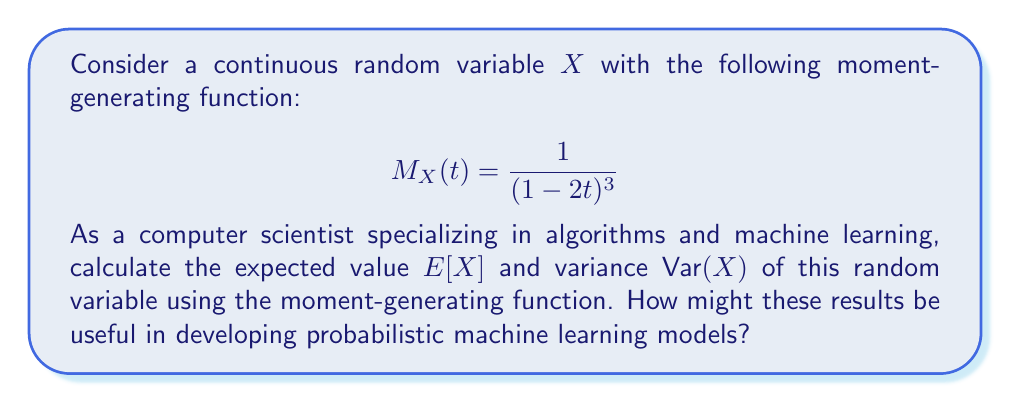Provide a solution to this math problem. To solve this problem, we'll use the properties of moment-generating functions (MGF) to calculate the expected value and variance.

Step 1: Calculate $E[X]$
The expected value is given by the first derivative of the MGF evaluated at $t=0$:

$$E[X] = M'_X(0)$$

Let's find $M'_X(t)$:

$$M'_X(t) = \frac{d}{dt}\left(\frac{1}{(1-2t)^3}\right) = \frac{6}{(1-2t)^4}$$

Now, evaluate at $t=0$:

$$E[X] = M'_X(0) = \frac{6}{(1-2(0))^4} = 6$$

Step 2: Calculate $E[X^2]$
To find the variance, we need $E[X^2]$, which is given by the second derivative of the MGF evaluated at $t=0$:

$$E[X^2] = M''_X(0)$$

Let's find $M''_X(t)$:

$$M''_X(t) = \frac{d}{dt}\left(\frac{6}{(1-2t)^4}\right) = \frac{48}{(1-2t)^5}$$

Evaluate at $t=0$:

$$E[X^2] = M''_X(0) = \frac{48}{(1-2(0))^5} = 48$$

Step 3: Calculate $\text{Var}(X)$
The variance is given by:

$$\text{Var}(X) = E[X^2] - (E[X])^2$$

Substituting the values we found:

$$\text{Var}(X) = 48 - 6^2 = 48 - 36 = 12$$

These results can be useful in developing probabilistic machine learning models by providing insights into the distribution's central tendency (expected value) and spread (variance). This information can be used for parameter estimation, model selection, and understanding the uncertainty in predictions.
Answer: $E[X] = 6$, $\text{Var}(X) = 12$ 